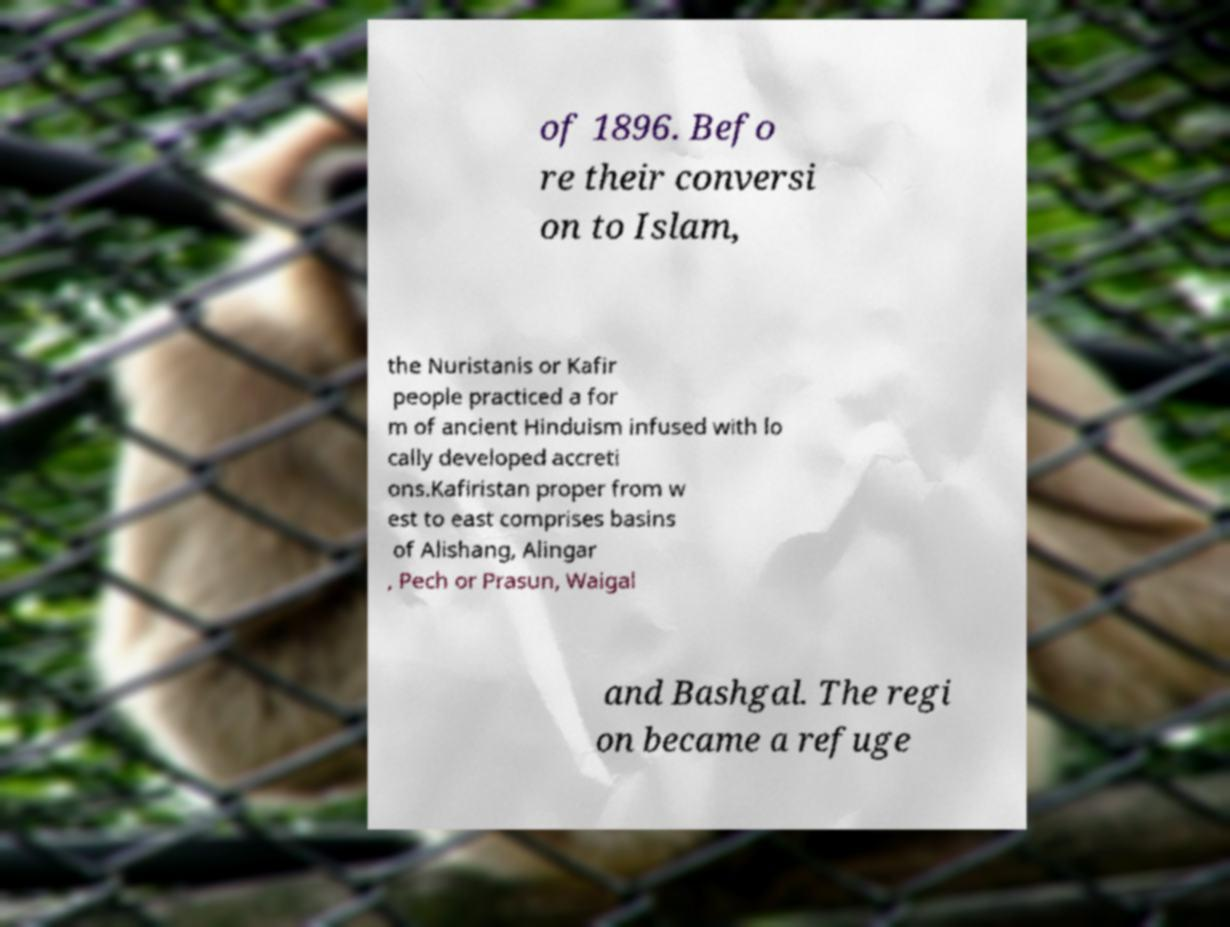Please read and relay the text visible in this image. What does it say? of 1896. Befo re their conversi on to Islam, the Nuristanis or Kafir people practiced a for m of ancient Hinduism infused with lo cally developed accreti ons.Kafiristan proper from w est to east comprises basins of Alishang, Alingar , Pech or Prasun, Waigal and Bashgal. The regi on became a refuge 